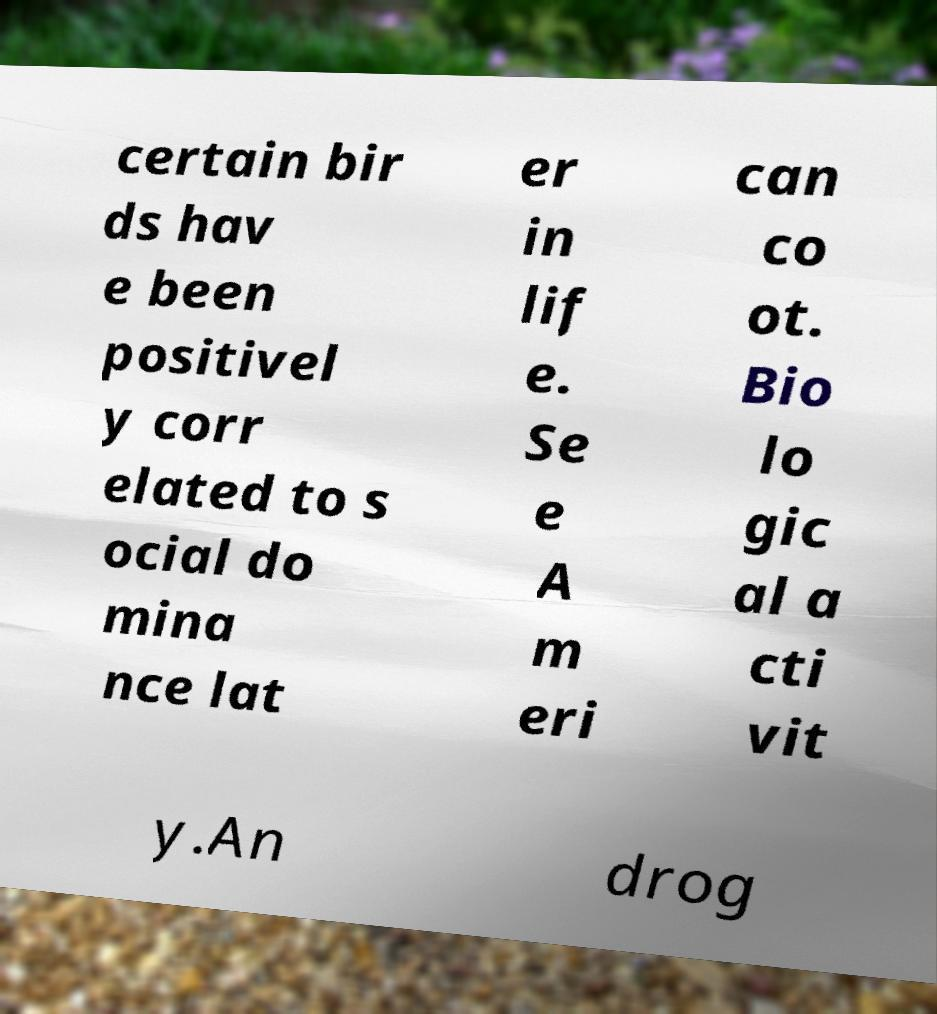Please identify and transcribe the text found in this image. certain bir ds hav e been positivel y corr elated to s ocial do mina nce lat er in lif e. Se e A m eri can co ot. Bio lo gic al a cti vit y.An drog 